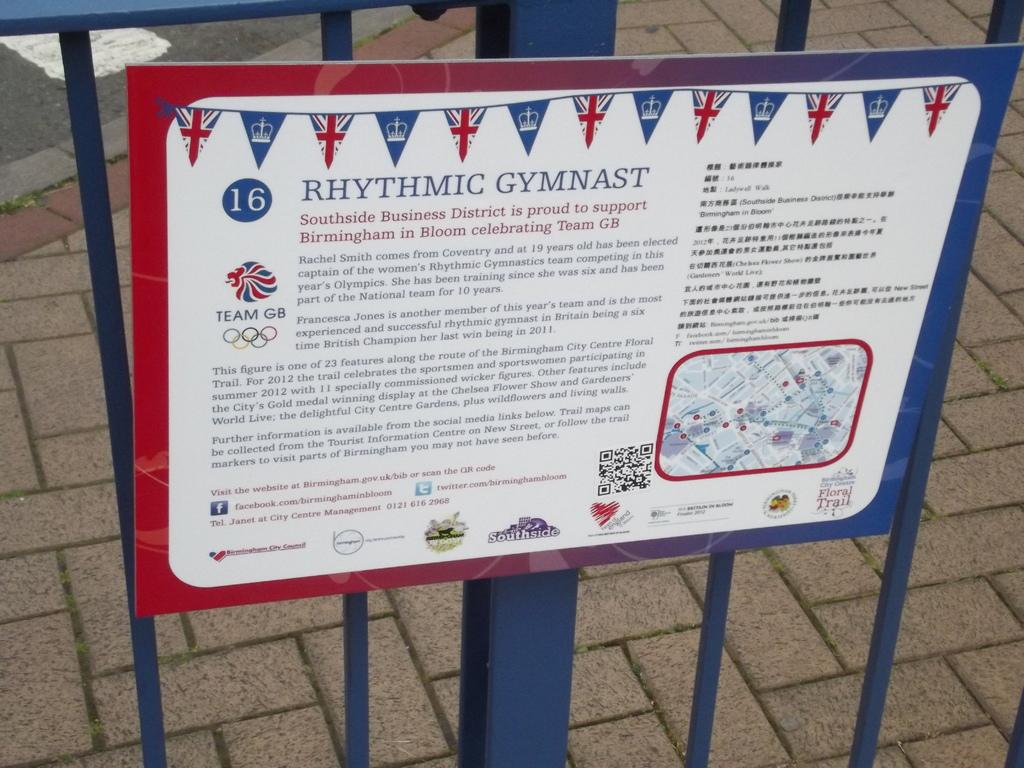<image>
Write a terse but informative summary of the picture. a sign that has rhythmic gymnast written on it 